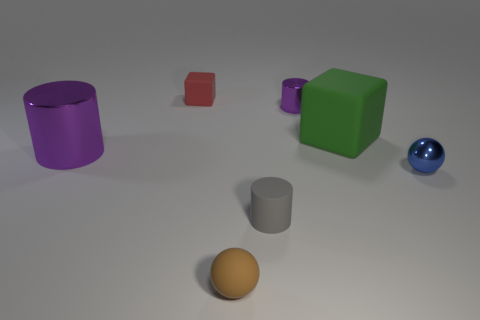Is there a pattern to the arrangement of the objects? There doesn't seem to be a deliberate pattern, but the objects are spaced out evenly across the surface with a variety of shapes and colors represented. Could this be a sample presentation of basic geometric shapes? Yes, it could potentially be an educational display of basic three-dimensional shapes, demonstrating the difference between various geometries and colors. 